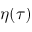Convert formula to latex. <formula><loc_0><loc_0><loc_500><loc_500>\eta ( \tau )</formula> 